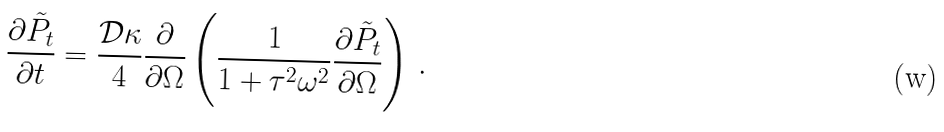<formula> <loc_0><loc_0><loc_500><loc_500>\frac { \partial { \tilde { P } } _ { t } } { \partial t } = \frac { \mathcal { D } \kappa } { 4 } \frac { \partial } { \partial \Omega } \left ( \frac { 1 } { 1 + \tau ^ { 2 } \omega ^ { 2 } } \frac { \partial { \tilde { P } } _ { t } } { \partial \Omega } \right ) \, .</formula> 